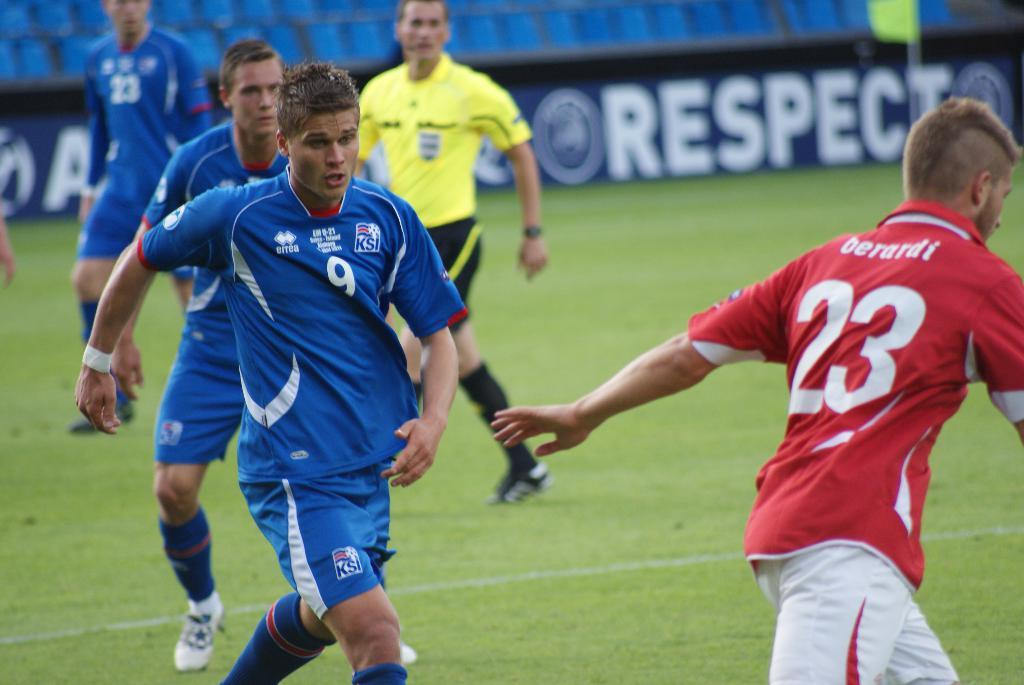<image>
Give a short and clear explanation of the subsequent image. Black banner at soccer field that reads RESPECT 